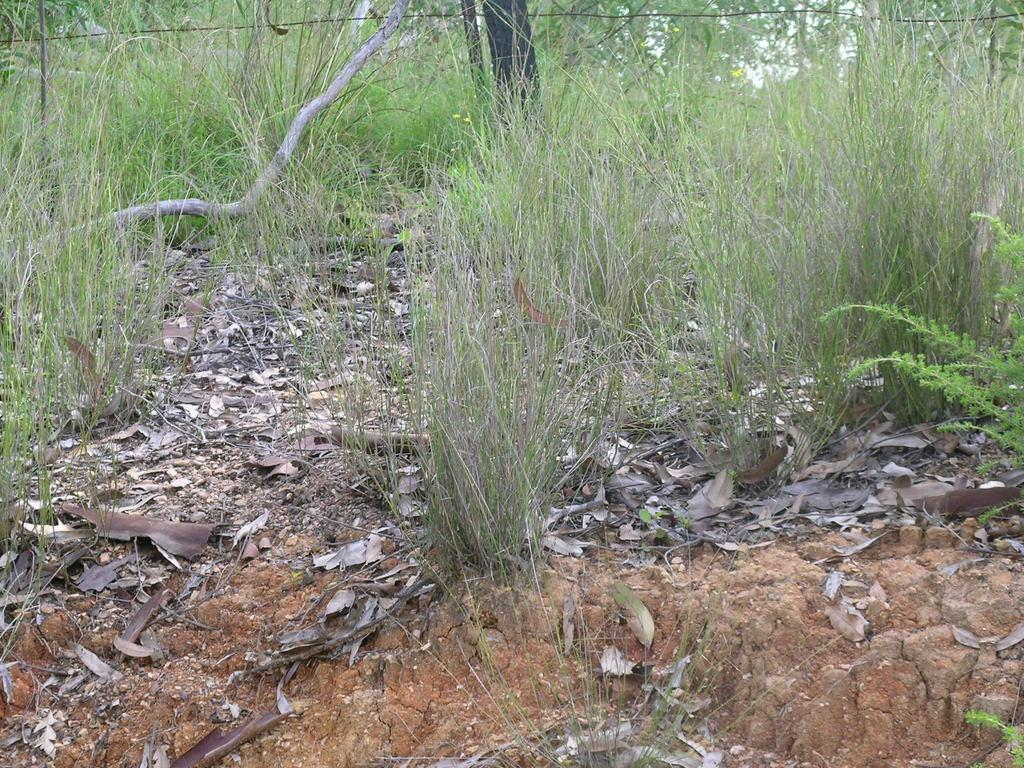What type of vegetation can be seen in the image? There is grass and plants in the image. What is covering the ground in the image? The ground is covered with dried leaves and mud. What type of materials are present in the image? There are wood elements and wires in the image. What is the rat's desire in the image? There is no rat present in the image, so it is not possible to determine its desires. 